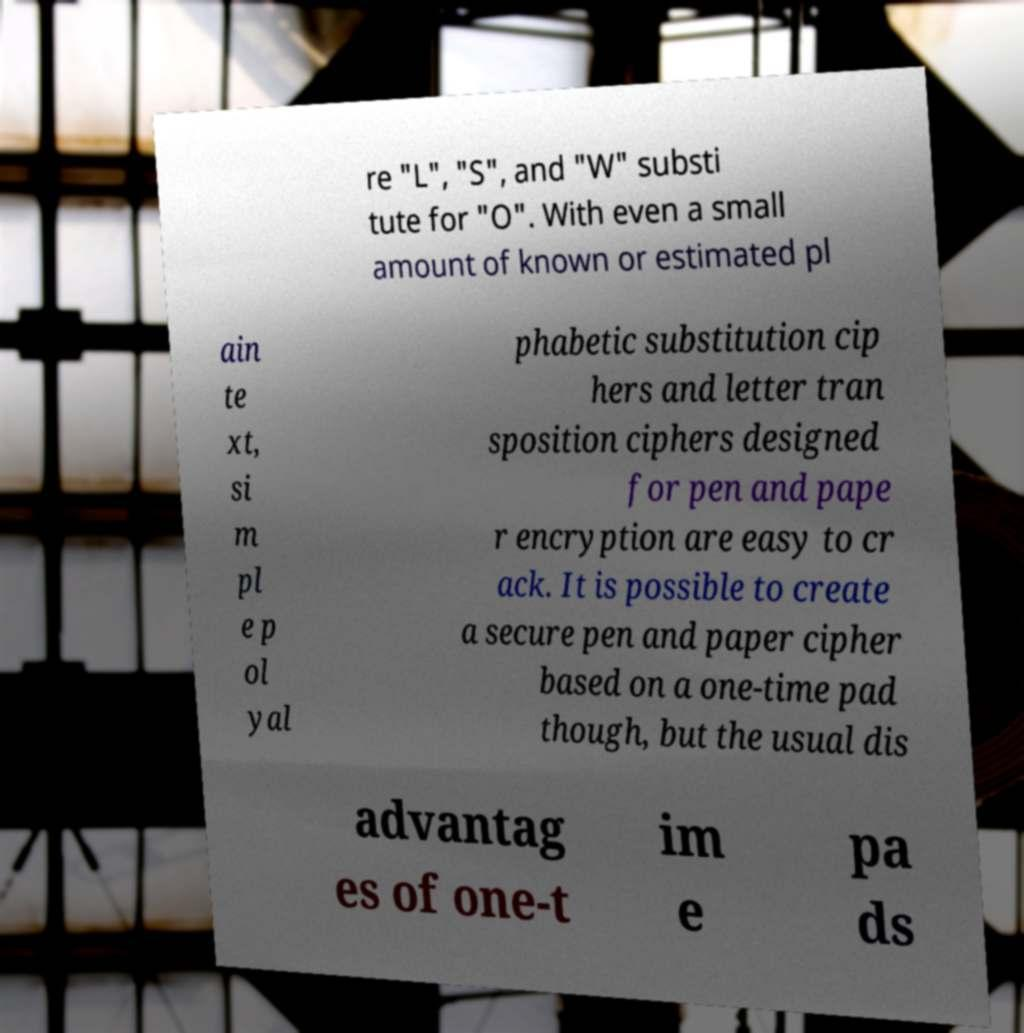Could you assist in decoding the text presented in this image and type it out clearly? re "L", "S", and "W" substi tute for "O". With even a small amount of known or estimated pl ain te xt, si m pl e p ol yal phabetic substitution cip hers and letter tran sposition ciphers designed for pen and pape r encryption are easy to cr ack. It is possible to create a secure pen and paper cipher based on a one-time pad though, but the usual dis advantag es of one-t im e pa ds 